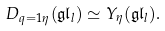Convert formula to latex. <formula><loc_0><loc_0><loc_500><loc_500>D _ { q = 1 \eta } ( \mathfrak { g l } _ { l } ) \simeq Y _ { \eta } ( \mathfrak { g l } _ { l } ) .</formula> 